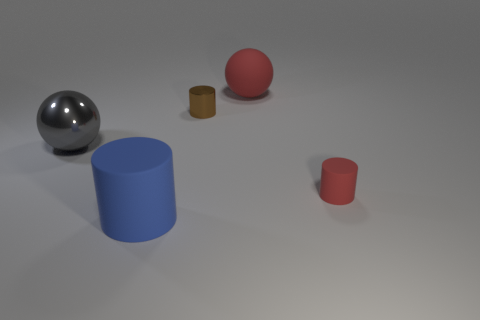There is a rubber thing that is to the left of the tiny cylinder that is behind the gray metallic ball; what number of tiny rubber objects are left of it?
Keep it short and to the point. 0. Is there any other thing that has the same size as the blue object?
Your answer should be compact. Yes. There is a red sphere; is its size the same as the red thing in front of the gray shiny thing?
Offer a very short reply. No. How many small gray shiny cylinders are there?
Ensure brevity in your answer.  0. Does the cylinder behind the large metal sphere have the same size as the matte cylinder that is on the right side of the red matte ball?
Ensure brevity in your answer.  Yes. What color is the other tiny thing that is the same shape as the small matte thing?
Your response must be concise. Brown. Does the tiny metallic thing have the same shape as the small red thing?
Give a very brief answer. Yes. There is a blue rubber thing that is the same shape as the brown metal object; what is its size?
Your response must be concise. Large. How many tiny yellow balls have the same material as the gray ball?
Keep it short and to the point. 0. How many things are small shiny cylinders or big red rubber things?
Give a very brief answer. 2. 